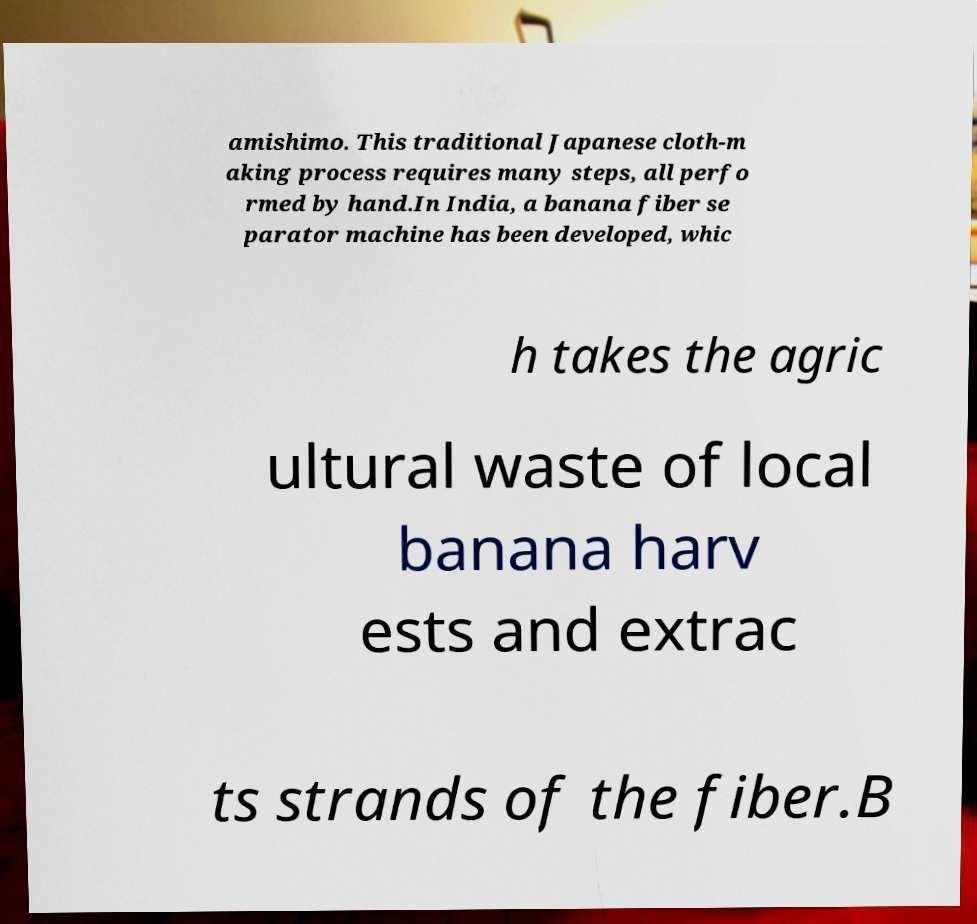I need the written content from this picture converted into text. Can you do that? amishimo. This traditional Japanese cloth-m aking process requires many steps, all perfo rmed by hand.In India, a banana fiber se parator machine has been developed, whic h takes the agric ultural waste of local banana harv ests and extrac ts strands of the fiber.B 